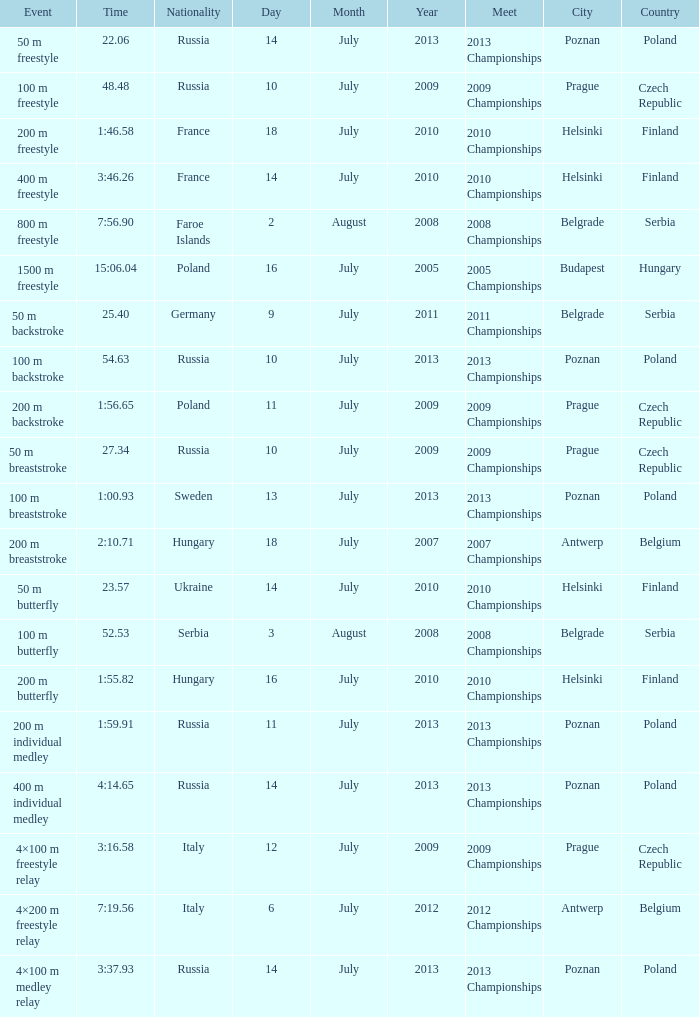What date was the 1500 m freestyle competition? 16 July 2005. 